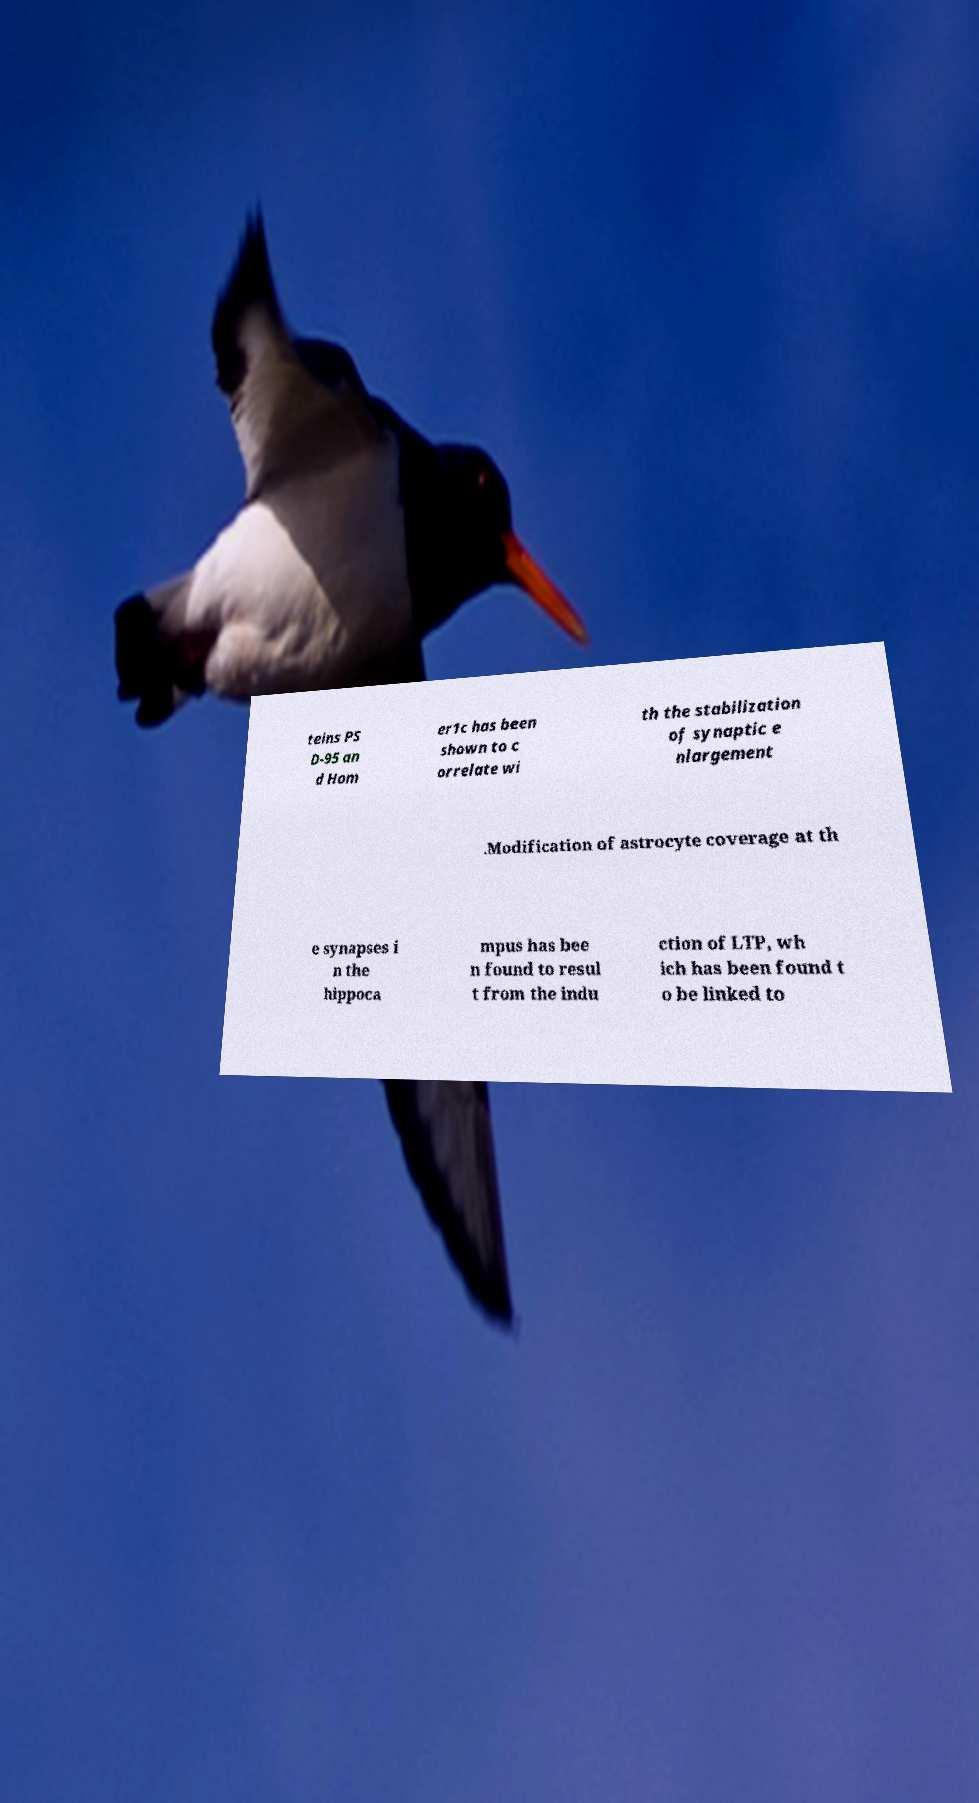Can you read and provide the text displayed in the image?This photo seems to have some interesting text. Can you extract and type it out for me? teins PS D-95 an d Hom er1c has been shown to c orrelate wi th the stabilization of synaptic e nlargement .Modification of astrocyte coverage at th e synapses i n the hippoca mpus has bee n found to resul t from the indu ction of LTP, wh ich has been found t o be linked to 